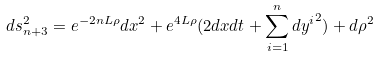<formula> <loc_0><loc_0><loc_500><loc_500>d s ^ { 2 } _ { n + 3 } = e ^ { - 2 n L \rho } d x ^ { 2 } + e ^ { 4 L \rho } ( 2 d x d t + \sum _ { i = 1 } ^ { n } { d y ^ { i } } ^ { 2 } ) + d \rho ^ { 2 }</formula> 